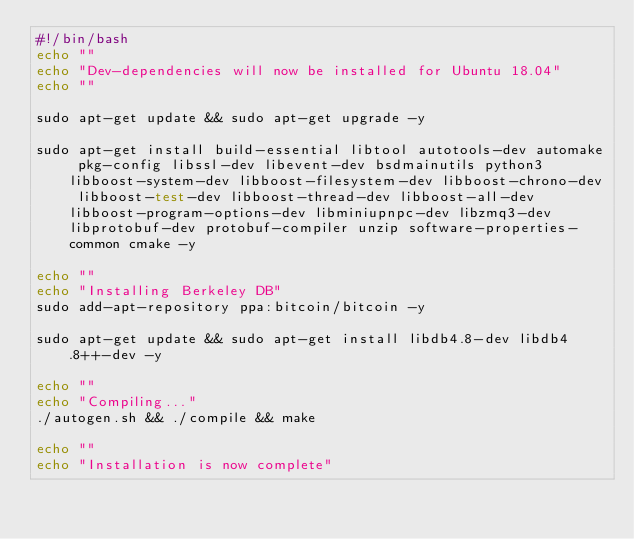Convert code to text. <code><loc_0><loc_0><loc_500><loc_500><_Bash_>#!/bin/bash
echo ""
echo "Dev-dependencies will now be installed for Ubuntu 18.04"
echo ""

sudo apt-get update && sudo apt-get upgrade -y

sudo apt-get install build-essential libtool autotools-dev automake pkg-config libssl-dev libevent-dev bsdmainutils python3 libboost-system-dev libboost-filesystem-dev libboost-chrono-dev libboost-test-dev libboost-thread-dev libboost-all-dev libboost-program-options-dev libminiupnpc-dev libzmq3-dev libprotobuf-dev protobuf-compiler unzip software-properties-common cmake -y

echo ""
echo "Installing Berkeley DB"
sudo add-apt-repository ppa:bitcoin/bitcoin -y

sudo apt-get update && sudo apt-get install libdb4.8-dev libdb4.8++-dev -y

echo ""
echo "Compiling..."
./autogen.sh && ./compile && make

echo ""
echo "Installation is now complete"
</code> 